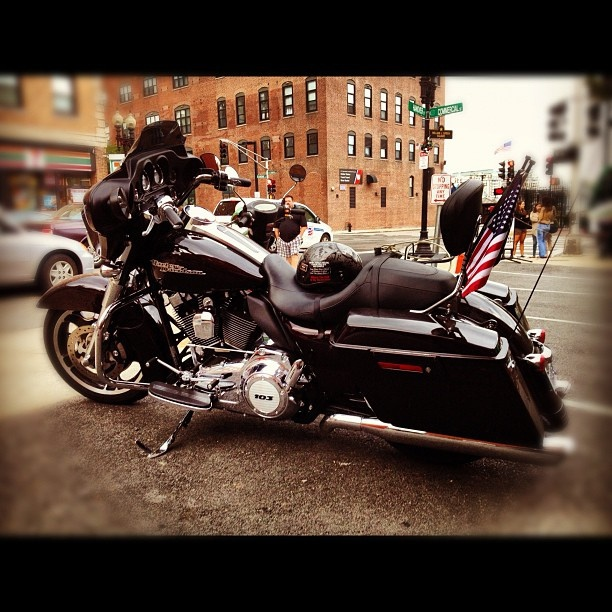Describe the objects in this image and their specific colors. I can see motorcycle in black, lightgray, maroon, and darkgray tones, car in black, lightgray, darkgray, and gray tones, car in black, darkgray, tan, and brown tones, car in black, ivory, maroon, and darkgray tones, and people in black, tan, and lightgray tones in this image. 